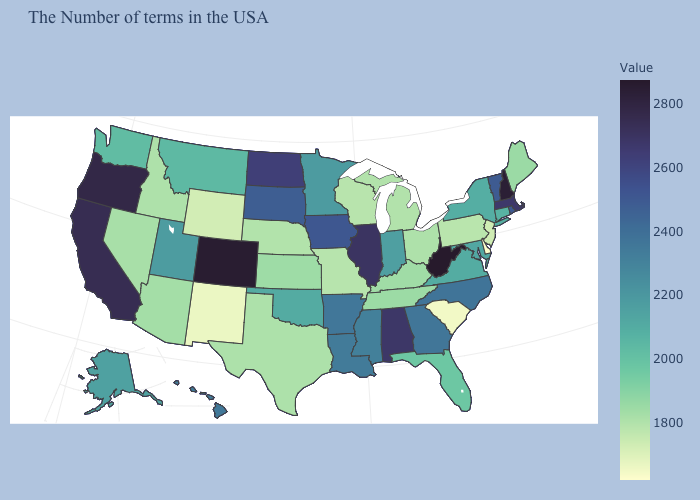Does Alaska have a lower value than Alabama?
Short answer required. Yes. Does Vermont have a lower value than Alabama?
Short answer required. Yes. Which states have the lowest value in the South?
Write a very short answer. Delaware. Among the states that border Wisconsin , which have the lowest value?
Keep it brief. Michigan. Which states have the lowest value in the West?
Give a very brief answer. New Mexico. 